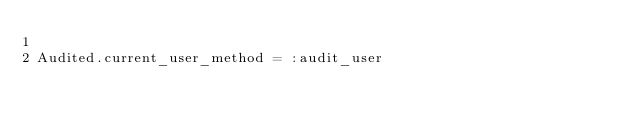<code> <loc_0><loc_0><loc_500><loc_500><_Ruby_>
Audited.current_user_method = :audit_user
</code> 